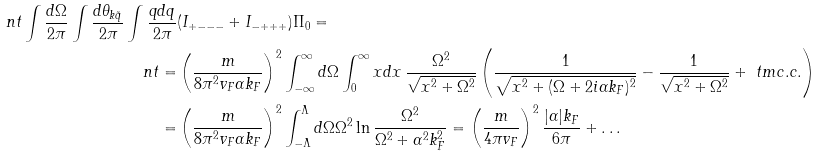<formula> <loc_0><loc_0><loc_500><loc_500>\ n t \int \frac { d \Omega } { 2 \pi } \int \frac { d \theta _ { k \tilde { q } } } { 2 \pi } \int \frac { q d q } { 2 \pi } & ( I _ { + - - - } + I _ { - + + + } ) \Pi _ { 0 } = \\ \ n t = & \left ( \frac { m } { 8 \pi ^ { 2 } v _ { F } \alpha k _ { F } } \right ) ^ { 2 } \int _ { - \infty } ^ { \infty } d \Omega \int _ { 0 } ^ { \infty } x d x \, \frac { \Omega ^ { 2 } } { \sqrt { x ^ { 2 } + \Omega ^ { 2 } } } \left ( \frac { 1 } { \sqrt { x ^ { 2 } + ( \Omega + 2 i \alpha k _ { F } ) ^ { 2 } } } - \frac { 1 } { \sqrt { x ^ { 2 } + \Omega ^ { 2 } } } + \ t m { c . c . } \right ) \\ = & \left ( \frac { m } { 8 \pi ^ { 2 } v _ { F } \alpha k _ { F } } \right ) ^ { 2 } \int _ { - \Lambda } ^ { \Lambda } d \Omega \Omega ^ { 2 } \ln \frac { \Omega ^ { 2 } } { \Omega ^ { 2 } + \alpha ^ { 2 } k _ { F } ^ { 2 } } = \left ( \frac { m } { 4 \pi v _ { F } } \right ) ^ { 2 } \frac { | \alpha | k _ { F } } { 6 \pi } + \dots</formula> 